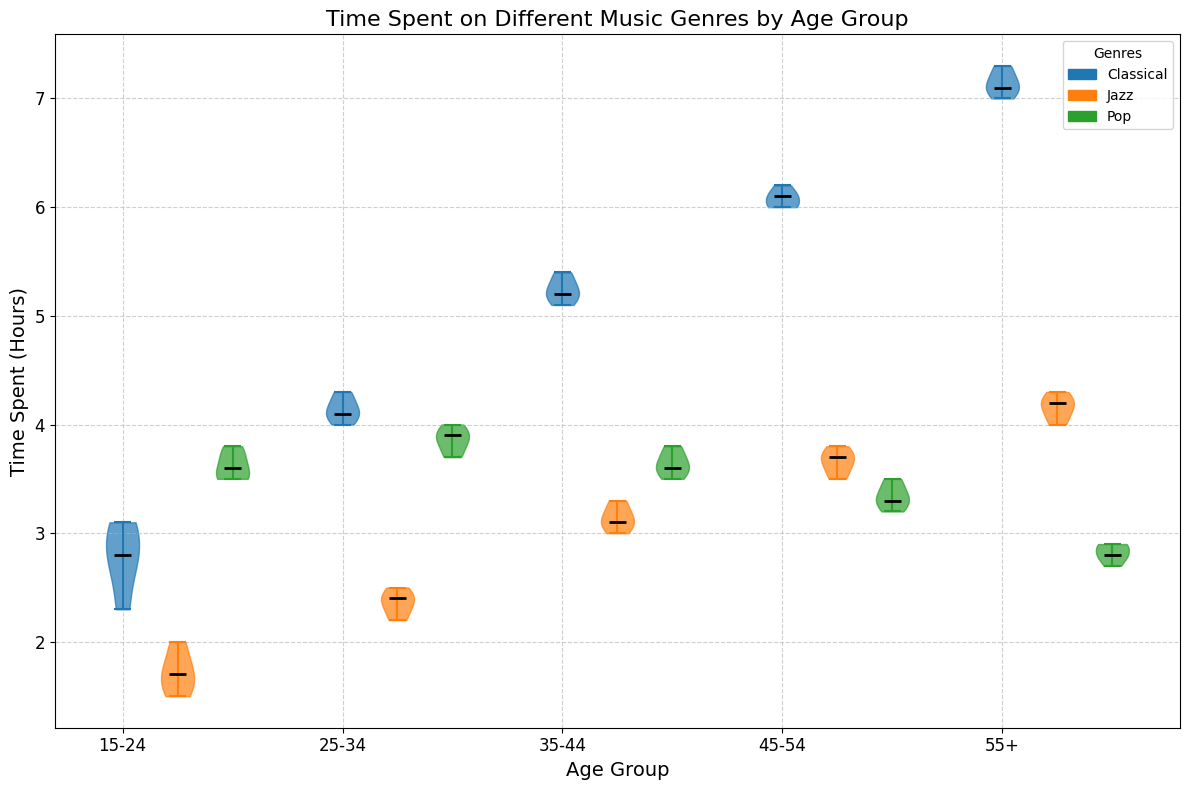How does the median time spent on Classical music for the age group 15-24 compare to the age group 55+? Look at the vertical lines (medians) within the violins for Classical music in the 15-24 group and the 55+ group. The median for 15-24 is around 2.9 hours, whereas the median for 55+ is around 7.1 hours.
Answer: 15-24's is less Which age group spends the most time on Jazz music, on average? By examining the spread of the violin plots for Jazz and the position of the median lines, the 55+ age group has the highest average time, indicated by the highest median around 4.2 hours.
Answer: 55+ What is the range of time spent on Pop music for the age group 45-54? The range can be found by looking at the upper and lower extremes of the violin plot for Pop in the 45-54 group. The lower end is around 3.2 hours and the upper end around 3.5 hours. Calculate 3.5 - 3.2 = 0.3 hours.
Answer: 0.3 hours Compare the median times spent listening to Classical music for the age groups 35-44 and 45-54. The median for the 35-44 group is around 5.2 hours, while the median for the 45-54 group is approximately 6.1 hours. Subtract 5.2 from 6.1.
Answer: 0.9 hours more for 45-54 Which genre has the most consistent time spent across all age groups? Consistency refers to less variation in the spread of the violin plots. By looking at spreads, Pop music across all age groups seems to have the most consistent spread.
Answer: Pop In the age group 25-34, which genre has the highest variability in time spent? Variability can be assessed by the width and spread of the violin plots. For the age group 25-34, Classical music has the highest variability in spread.
Answer: Classical For the age group 55+, how does the time spent on Jazz compare to Pop? By comparing the median lines of the two genres for the 55+ group, Jazz has a median around 4.2 hours, while Pop is around 2.8 hours.
Answer: Jazz is more What is the difference in median time spent on Classical music between the age groups 15-24 and 35-44? The median for 15-24 is about 2.9 hours, and for 35-44, it is around 5.2 hours. Subtracting 2.9 from 5.2 gives 2.3 hours.
Answer: 2.3 hours Which age group shows the highest median time spent on any genre? Look at all median lines across all age groups and genres. The highest median is for Classical music in the 55+ group at about 7.1 hours.
Answer: 55+ 